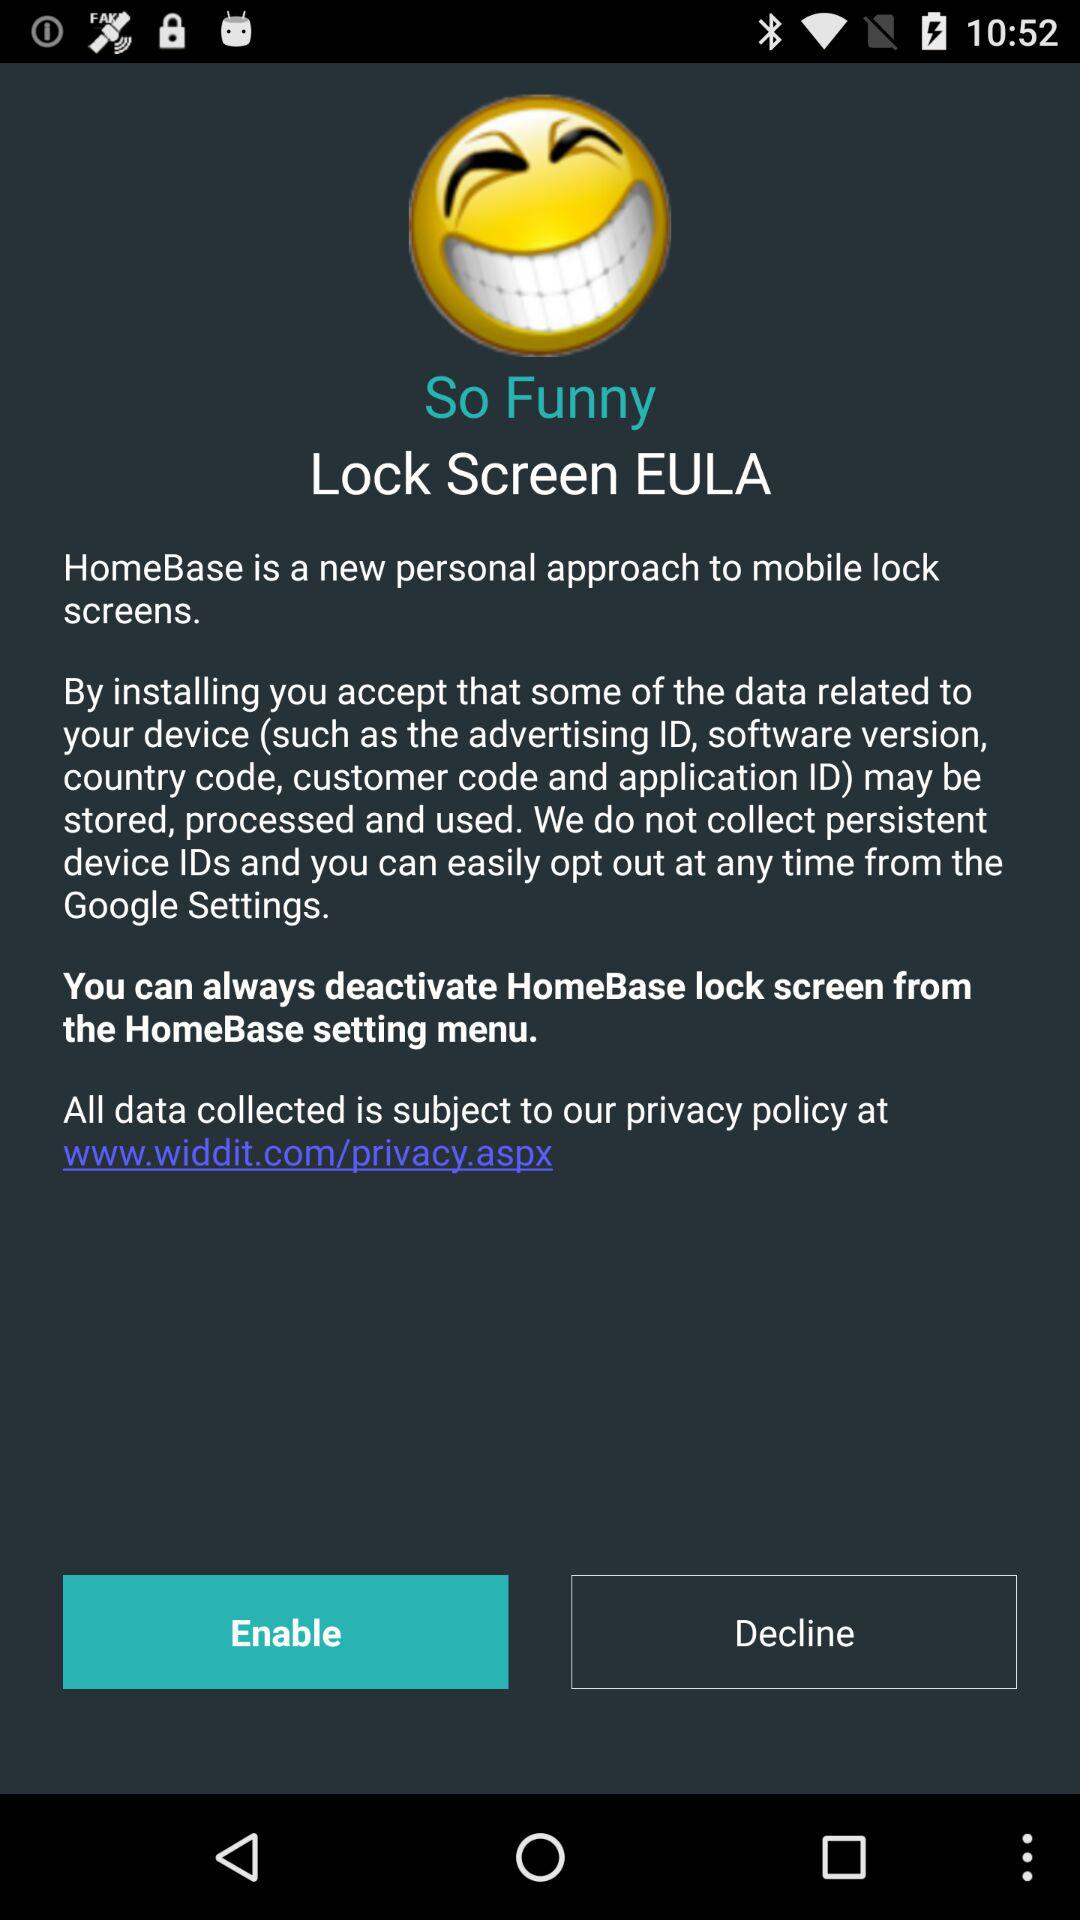What's the website address? The website address is www.widdit.com/privacy.aspx. 